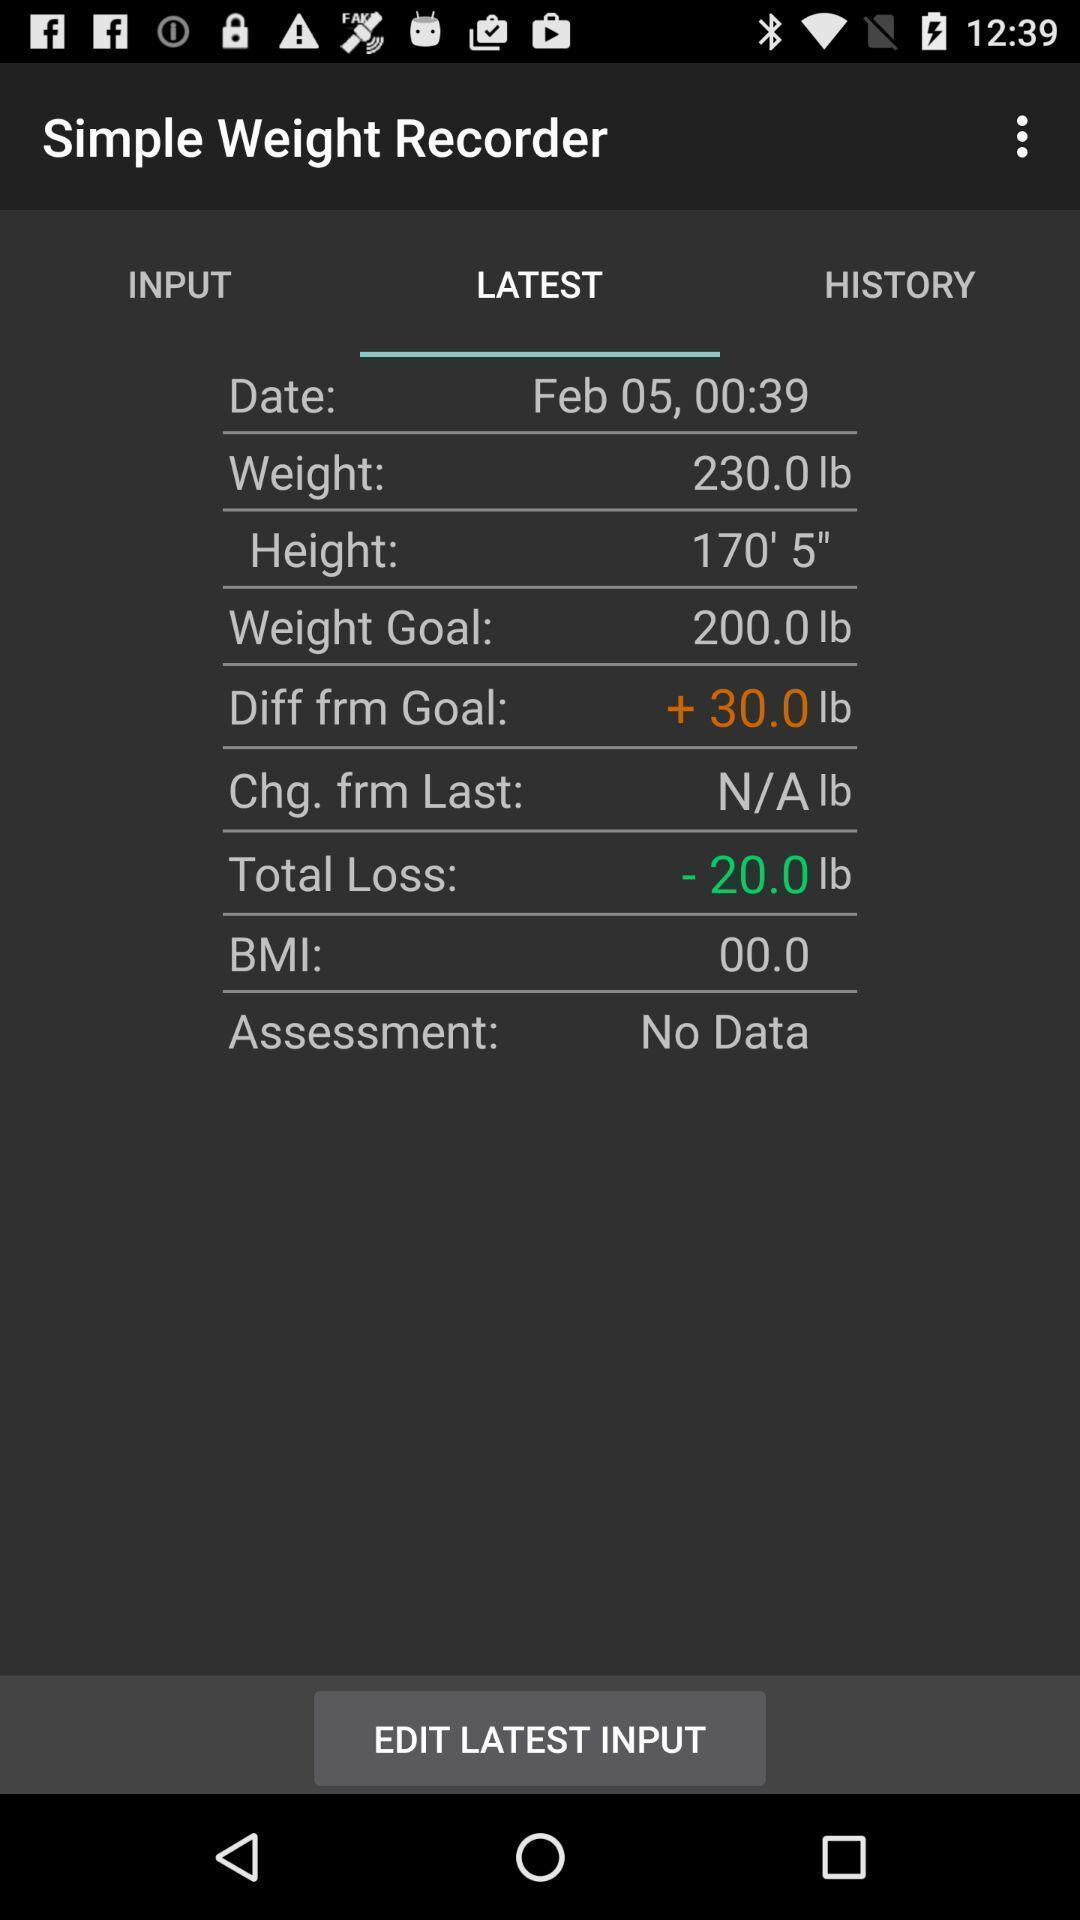What is the overall content of this screenshot? Screen shows tracking in a weight recorder app. 